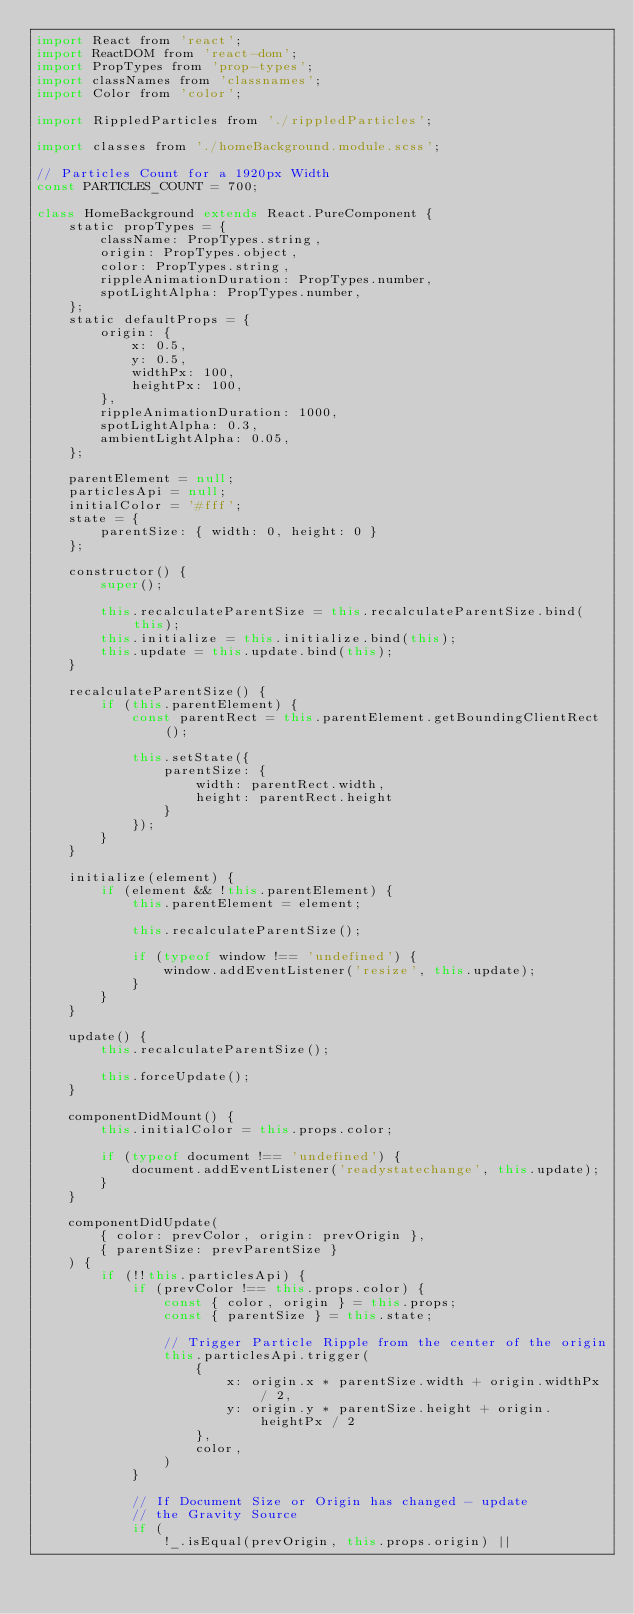Convert code to text. <code><loc_0><loc_0><loc_500><loc_500><_JavaScript_>import React from 'react';
import ReactDOM from 'react-dom';
import PropTypes from 'prop-types';
import classNames from 'classnames';
import Color from 'color';

import RippledParticles from './rippledParticles';

import classes from './homeBackground.module.scss';

// Particles Count for a 1920px Width
const PARTICLES_COUNT = 700;

class HomeBackground extends React.PureComponent {
    static propTypes = {
        className: PropTypes.string,
        origin: PropTypes.object,
        color: PropTypes.string,
        rippleAnimationDuration: PropTypes.number,
        spotLightAlpha: PropTypes.number,
    };
    static defaultProps = {
        origin: {
            x: 0.5,
            y: 0.5,
            widthPx: 100,
            heightPx: 100,
        },
        rippleAnimationDuration: 1000,
        spotLightAlpha: 0.3,
        ambientLightAlpha: 0.05,
    };

    parentElement = null;
    particlesApi = null;
    initialColor = '#fff';
    state = {
        parentSize: { width: 0, height: 0 }
    };

    constructor() {
        super();

        this.recalculateParentSize = this.recalculateParentSize.bind(this);
        this.initialize = this.initialize.bind(this);
        this.update = this.update.bind(this);
    }

    recalculateParentSize() {
        if (this.parentElement) {
            const parentRect = this.parentElement.getBoundingClientRect();

            this.setState({
                parentSize: {
                    width: parentRect.width,
                    height: parentRect.height
                }
            });
        }
    }

    initialize(element) {
        if (element && !this.parentElement) {
            this.parentElement = element;
        
            this.recalculateParentSize();

            if (typeof window !== 'undefined') {
                window.addEventListener('resize', this.update);
            }
        }
    }

    update() {
        this.recalculateParentSize();

        this.forceUpdate();
    }

    componentDidMount() {
        this.initialColor = this.props.color;
        
        if (typeof document !== 'undefined') {
            document.addEventListener('readystatechange', this.update);
        }
    }

    componentDidUpdate(
        { color: prevColor, origin: prevOrigin },
        { parentSize: prevParentSize }
    ) {
        if (!!this.particlesApi) {
            if (prevColor !== this.props.color) {
                const { color, origin } = this.props;
                const { parentSize } = this.state;
    
                // Trigger Particle Ripple from the center of the origin
                this.particlesApi.trigger(
                    {
                        x: origin.x * parentSize.width + origin.widthPx / 2,
                        y: origin.y * parentSize.height + origin.heightPx / 2
                    },
                    color,
                )
            }
    
            // If Document Size or Origin has changed - update
            // the Gravity Source
            if (
                !_.isEqual(prevOrigin, this.props.origin) ||</code> 